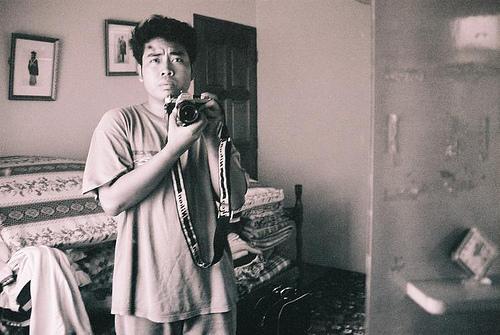Is the man looking into the camera?
Short answer required. No. How many people are in the pictures on the wall?
Write a very short answer. 2. What is the man holding in his hand as he looks off?
Quick response, please. Camera. Is he a monk?
Write a very short answer. No. 